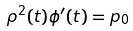<formula> <loc_0><loc_0><loc_500><loc_500>\rho ^ { 2 } ( t ) \phi ^ { \prime } ( t ) = p _ { 0 }</formula> 